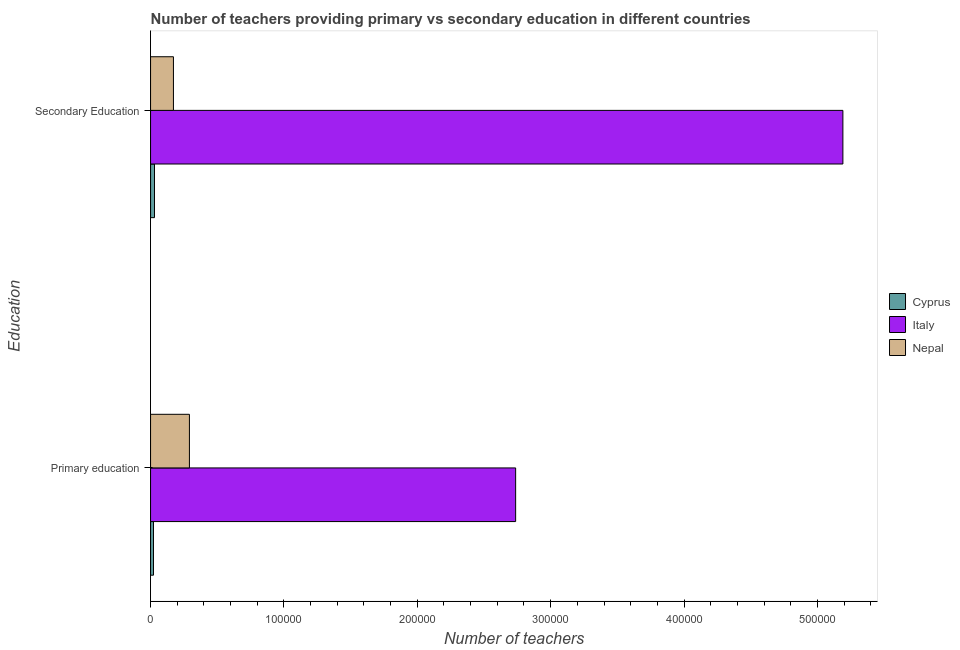How many different coloured bars are there?
Give a very brief answer. 3. How many groups of bars are there?
Ensure brevity in your answer.  2. Are the number of bars per tick equal to the number of legend labels?
Your answer should be compact. Yes. How many bars are there on the 2nd tick from the top?
Your answer should be very brief. 3. How many bars are there on the 1st tick from the bottom?
Provide a short and direct response. 3. What is the label of the 2nd group of bars from the top?
Offer a terse response. Primary education. What is the number of primary teachers in Italy?
Ensure brevity in your answer.  2.74e+05. Across all countries, what is the maximum number of secondary teachers?
Ensure brevity in your answer.  5.19e+05. Across all countries, what is the minimum number of secondary teachers?
Your answer should be compact. 2953. In which country was the number of primary teachers minimum?
Offer a terse response. Cyprus. What is the total number of primary teachers in the graph?
Offer a terse response. 3.05e+05. What is the difference between the number of secondary teachers in Italy and that in Cyprus?
Your answer should be compact. 5.16e+05. What is the difference between the number of primary teachers in Italy and the number of secondary teachers in Nepal?
Offer a terse response. 2.57e+05. What is the average number of primary teachers per country?
Offer a very short reply. 1.02e+05. What is the difference between the number of primary teachers and number of secondary teachers in Cyprus?
Give a very brief answer. -760. In how many countries, is the number of primary teachers greater than 440000 ?
Offer a very short reply. 0. What is the ratio of the number of primary teachers in Nepal to that in Italy?
Your response must be concise. 0.11. What does the 3rd bar from the top in Secondary Education represents?
Ensure brevity in your answer.  Cyprus. What does the 2nd bar from the bottom in Primary education represents?
Your answer should be compact. Italy. What is the difference between two consecutive major ticks on the X-axis?
Offer a terse response. 1.00e+05. How many legend labels are there?
Ensure brevity in your answer.  3. How are the legend labels stacked?
Make the answer very short. Vertical. What is the title of the graph?
Offer a terse response. Number of teachers providing primary vs secondary education in different countries. What is the label or title of the X-axis?
Your answer should be very brief. Number of teachers. What is the label or title of the Y-axis?
Ensure brevity in your answer.  Education. What is the Number of teachers in Cyprus in Primary education?
Give a very brief answer. 2193. What is the Number of teachers in Italy in Primary education?
Offer a very short reply. 2.74e+05. What is the Number of teachers in Nepal in Primary education?
Your response must be concise. 2.91e+04. What is the Number of teachers of Cyprus in Secondary Education?
Keep it short and to the point. 2953. What is the Number of teachers in Italy in Secondary Education?
Ensure brevity in your answer.  5.19e+05. What is the Number of teachers of Nepal in Secondary Education?
Your answer should be compact. 1.72e+04. Across all Education, what is the maximum Number of teachers in Cyprus?
Offer a terse response. 2953. Across all Education, what is the maximum Number of teachers in Italy?
Your answer should be compact. 5.19e+05. Across all Education, what is the maximum Number of teachers in Nepal?
Give a very brief answer. 2.91e+04. Across all Education, what is the minimum Number of teachers in Cyprus?
Ensure brevity in your answer.  2193. Across all Education, what is the minimum Number of teachers of Italy?
Offer a terse response. 2.74e+05. Across all Education, what is the minimum Number of teachers in Nepal?
Provide a short and direct response. 1.72e+04. What is the total Number of teachers of Cyprus in the graph?
Your answer should be very brief. 5146. What is the total Number of teachers of Italy in the graph?
Offer a terse response. 7.93e+05. What is the total Number of teachers in Nepal in the graph?
Provide a short and direct response. 4.63e+04. What is the difference between the Number of teachers in Cyprus in Primary education and that in Secondary Education?
Provide a short and direct response. -760. What is the difference between the Number of teachers of Italy in Primary education and that in Secondary Education?
Provide a short and direct response. -2.45e+05. What is the difference between the Number of teachers in Nepal in Primary education and that in Secondary Education?
Your answer should be very brief. 1.20e+04. What is the difference between the Number of teachers in Cyprus in Primary education and the Number of teachers in Italy in Secondary Education?
Ensure brevity in your answer.  -5.17e+05. What is the difference between the Number of teachers in Cyprus in Primary education and the Number of teachers in Nepal in Secondary Education?
Offer a terse response. -1.50e+04. What is the difference between the Number of teachers of Italy in Primary education and the Number of teachers of Nepal in Secondary Education?
Give a very brief answer. 2.57e+05. What is the average Number of teachers in Cyprus per Education?
Provide a succinct answer. 2573. What is the average Number of teachers of Italy per Education?
Provide a short and direct response. 3.96e+05. What is the average Number of teachers in Nepal per Education?
Make the answer very short. 2.31e+04. What is the difference between the Number of teachers of Cyprus and Number of teachers of Italy in Primary education?
Your answer should be very brief. -2.72e+05. What is the difference between the Number of teachers in Cyprus and Number of teachers in Nepal in Primary education?
Make the answer very short. -2.69e+04. What is the difference between the Number of teachers in Italy and Number of teachers in Nepal in Primary education?
Provide a succinct answer. 2.45e+05. What is the difference between the Number of teachers in Cyprus and Number of teachers in Italy in Secondary Education?
Provide a short and direct response. -5.16e+05. What is the difference between the Number of teachers in Cyprus and Number of teachers in Nepal in Secondary Education?
Make the answer very short. -1.42e+04. What is the difference between the Number of teachers of Italy and Number of teachers of Nepal in Secondary Education?
Provide a short and direct response. 5.02e+05. What is the ratio of the Number of teachers of Cyprus in Primary education to that in Secondary Education?
Ensure brevity in your answer.  0.74. What is the ratio of the Number of teachers of Italy in Primary education to that in Secondary Education?
Your response must be concise. 0.53. What is the ratio of the Number of teachers of Nepal in Primary education to that in Secondary Education?
Keep it short and to the point. 1.7. What is the difference between the highest and the second highest Number of teachers in Cyprus?
Offer a very short reply. 760. What is the difference between the highest and the second highest Number of teachers of Italy?
Keep it short and to the point. 2.45e+05. What is the difference between the highest and the second highest Number of teachers in Nepal?
Keep it short and to the point. 1.20e+04. What is the difference between the highest and the lowest Number of teachers of Cyprus?
Your answer should be compact. 760. What is the difference between the highest and the lowest Number of teachers in Italy?
Provide a short and direct response. 2.45e+05. What is the difference between the highest and the lowest Number of teachers in Nepal?
Offer a very short reply. 1.20e+04. 